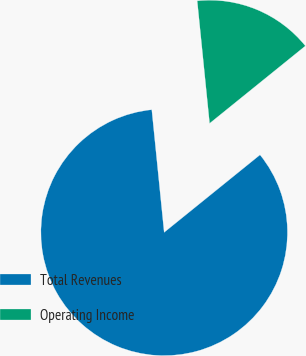Convert chart. <chart><loc_0><loc_0><loc_500><loc_500><pie_chart><fcel>Total Revenues<fcel>Operating Income<nl><fcel>84.22%<fcel>15.78%<nl></chart> 